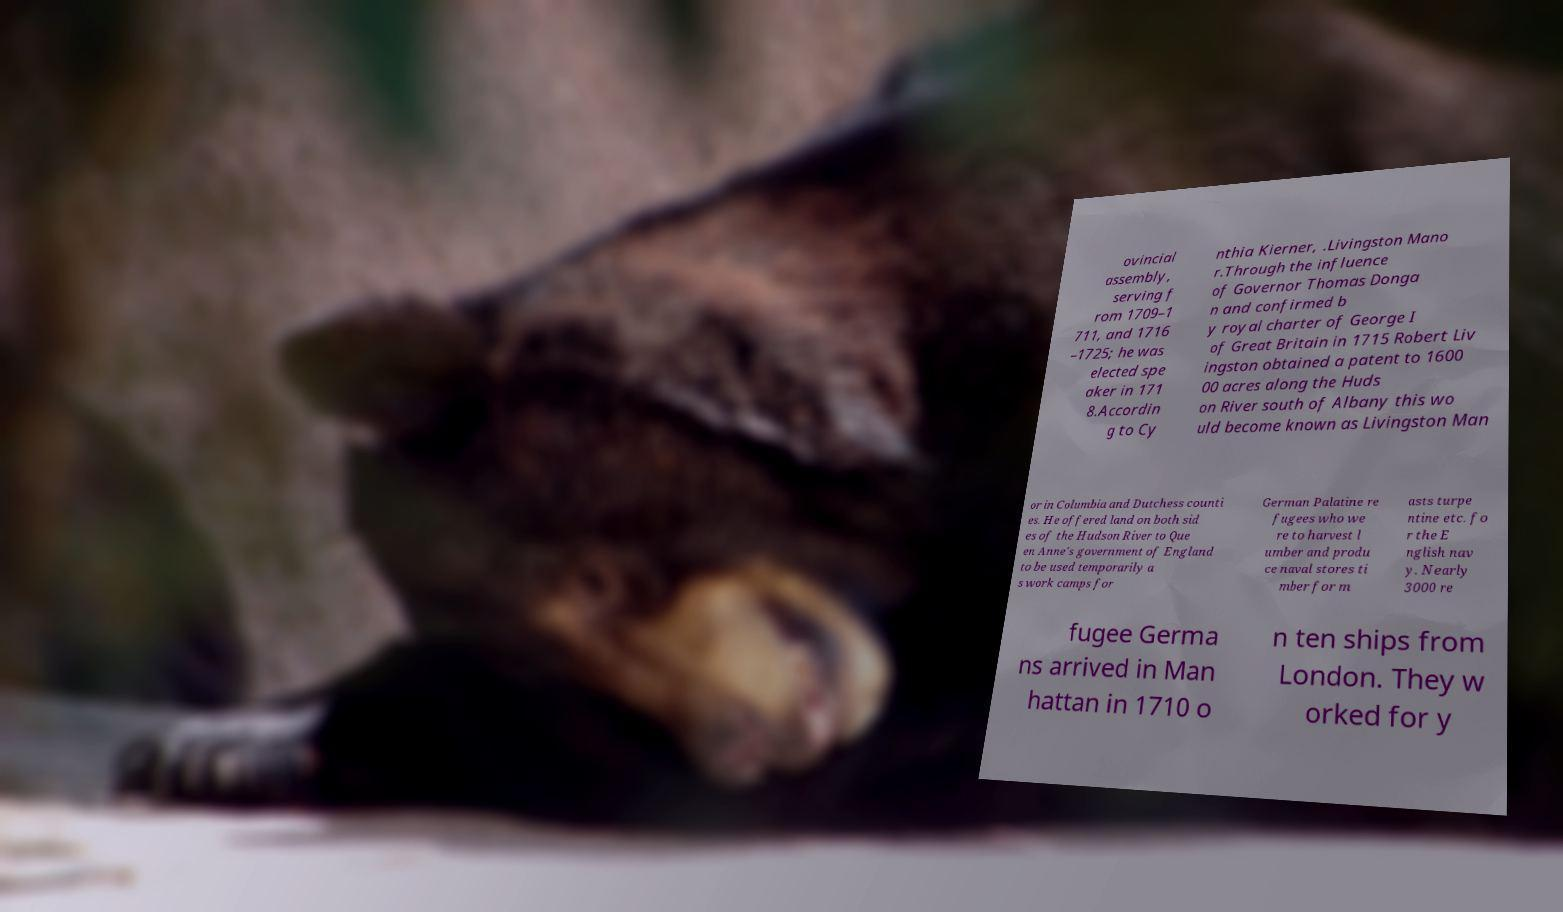Please identify and transcribe the text found in this image. ovincial assembly, serving f rom 1709–1 711, and 1716 –1725; he was elected spe aker in 171 8.Accordin g to Cy nthia Kierner, .Livingston Mano r.Through the influence of Governor Thomas Donga n and confirmed b y royal charter of George I of Great Britain in 1715 Robert Liv ingston obtained a patent to 1600 00 acres along the Huds on River south of Albany this wo uld become known as Livingston Man or in Columbia and Dutchess counti es. He offered land on both sid es of the Hudson River to Que en Anne's government of England to be used temporarily a s work camps for German Palatine re fugees who we re to harvest l umber and produ ce naval stores ti mber for m asts turpe ntine etc. fo r the E nglish nav y. Nearly 3000 re fugee Germa ns arrived in Man hattan in 1710 o n ten ships from London. They w orked for y 